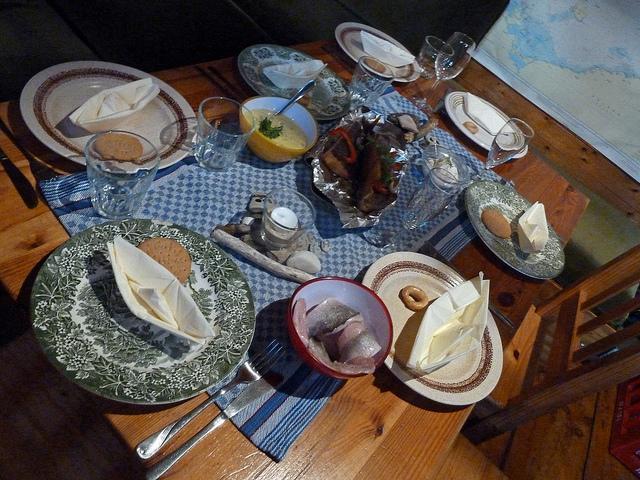What are the napkins folded to look like?
Choose the correct response, then elucidate: 'Answer: answer
Rationale: rationale.'
Options: Boats, cars, plane, fans. Answer: boats.
Rationale: The napkins look like sailboats. 